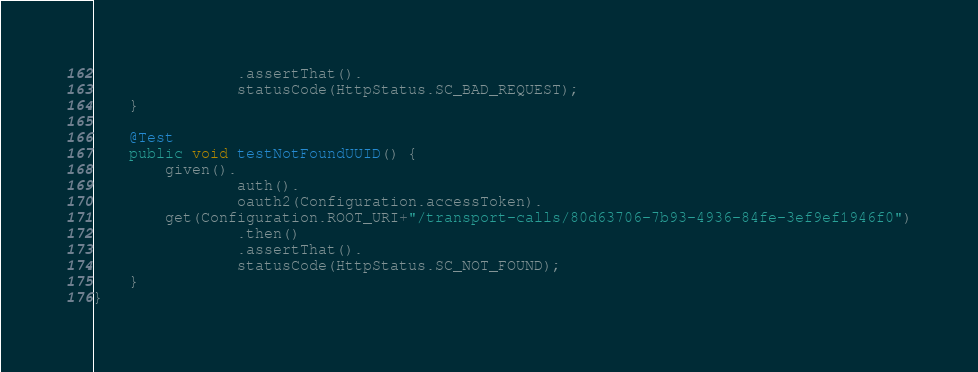Convert code to text. <code><loc_0><loc_0><loc_500><loc_500><_Java_>                .assertThat().
                statusCode(HttpStatus.SC_BAD_REQUEST);
    }

    @Test
    public void testNotFoundUUID() {
        given().
                auth().
                oauth2(Configuration.accessToken).
        get(Configuration.ROOT_URI+"/transport-calls/80d63706-7b93-4936-84fe-3ef9ef1946f0")
                .then()
                .assertThat().
                statusCode(HttpStatus.SC_NOT_FOUND);
    }
}
</code> 